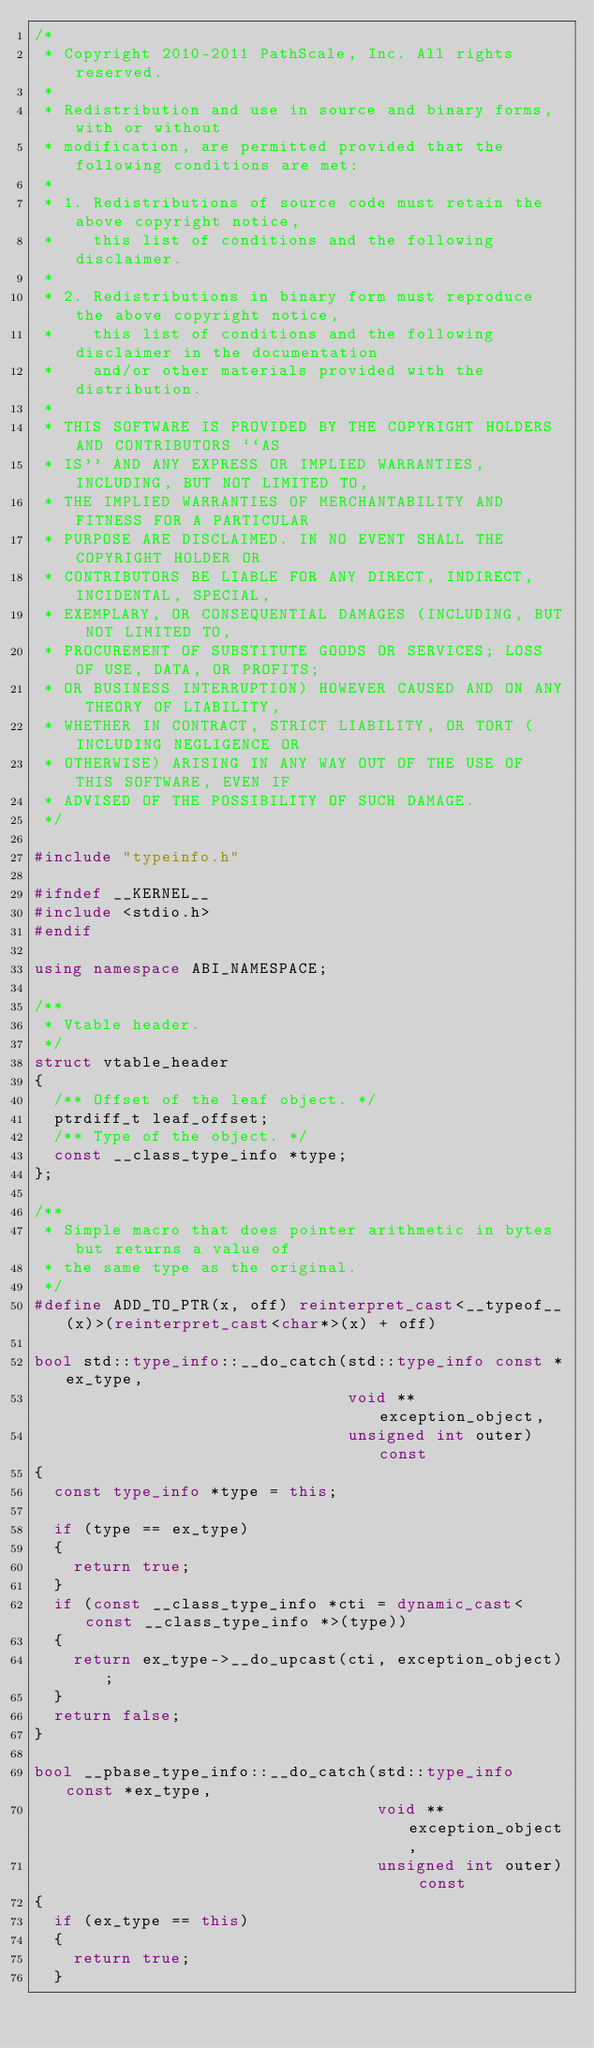<code> <loc_0><loc_0><loc_500><loc_500><_C++_>/* 
 * Copyright 2010-2011 PathScale, Inc. All rights reserved.
 *
 * Redistribution and use in source and binary forms, with or without
 * modification, are permitted provided that the following conditions are met:
 *
 * 1. Redistributions of source code must retain the above copyright notice,
 *    this list of conditions and the following disclaimer.
 *
 * 2. Redistributions in binary form must reproduce the above copyright notice,
 *    this list of conditions and the following disclaimer in the documentation
 *    and/or other materials provided with the distribution.
 * 
 * THIS SOFTWARE IS PROVIDED BY THE COPYRIGHT HOLDERS AND CONTRIBUTORS ``AS
 * IS'' AND ANY EXPRESS OR IMPLIED WARRANTIES, INCLUDING, BUT NOT LIMITED TO,
 * THE IMPLIED WARRANTIES OF MERCHANTABILITY AND FITNESS FOR A PARTICULAR
 * PURPOSE ARE DISCLAIMED. IN NO EVENT SHALL THE COPYRIGHT HOLDER OR
 * CONTRIBUTORS BE LIABLE FOR ANY DIRECT, INDIRECT, INCIDENTAL, SPECIAL,
 * EXEMPLARY, OR CONSEQUENTIAL DAMAGES (INCLUDING, BUT NOT LIMITED TO,
 * PROCUREMENT OF SUBSTITUTE GOODS OR SERVICES; LOSS OF USE, DATA, OR PROFITS;
 * OR BUSINESS INTERRUPTION) HOWEVER CAUSED AND ON ANY THEORY OF LIABILITY,
 * WHETHER IN CONTRACT, STRICT LIABILITY, OR TORT (INCLUDING NEGLIGENCE OR
 * OTHERWISE) ARISING IN ANY WAY OUT OF THE USE OF THIS SOFTWARE, EVEN IF
 * ADVISED OF THE POSSIBILITY OF SUCH DAMAGE.
 */

#include "typeinfo.h"

#ifndef __KERNEL__
#include <stdio.h>
#endif

using namespace ABI_NAMESPACE;

/**
 * Vtable header.
 */
struct vtable_header
{
	/** Offset of the leaf object. */
	ptrdiff_t leaf_offset;
	/** Type of the object. */
	const __class_type_info *type;
};

/**
 * Simple macro that does pointer arithmetic in bytes but returns a value of
 * the same type as the original.
 */
#define ADD_TO_PTR(x, off) reinterpret_cast<__typeof__(x)>(reinterpret_cast<char*>(x) + off)

bool std::type_info::__do_catch(std::type_info const *ex_type,
                                void **exception_object,
                                unsigned int outer) const
{
	const type_info *type = this;

	if (type == ex_type)
	{
		return true;
	}
	if (const __class_type_info *cti = dynamic_cast<const __class_type_info *>(type))
	{
		return ex_type->__do_upcast(cti, exception_object);
	}
	return false;
}

bool __pbase_type_info::__do_catch(std::type_info const *ex_type,
                                   void **exception_object,
                                   unsigned int outer) const
{
	if (ex_type == this)
	{
		return true;
	}</code> 